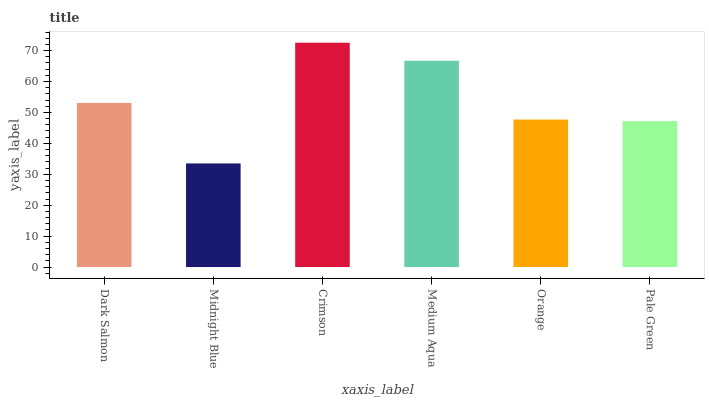Is Midnight Blue the minimum?
Answer yes or no. Yes. Is Crimson the maximum?
Answer yes or no. Yes. Is Crimson the minimum?
Answer yes or no. No. Is Midnight Blue the maximum?
Answer yes or no. No. Is Crimson greater than Midnight Blue?
Answer yes or no. Yes. Is Midnight Blue less than Crimson?
Answer yes or no. Yes. Is Midnight Blue greater than Crimson?
Answer yes or no. No. Is Crimson less than Midnight Blue?
Answer yes or no. No. Is Dark Salmon the high median?
Answer yes or no. Yes. Is Orange the low median?
Answer yes or no. Yes. Is Orange the high median?
Answer yes or no. No. Is Midnight Blue the low median?
Answer yes or no. No. 